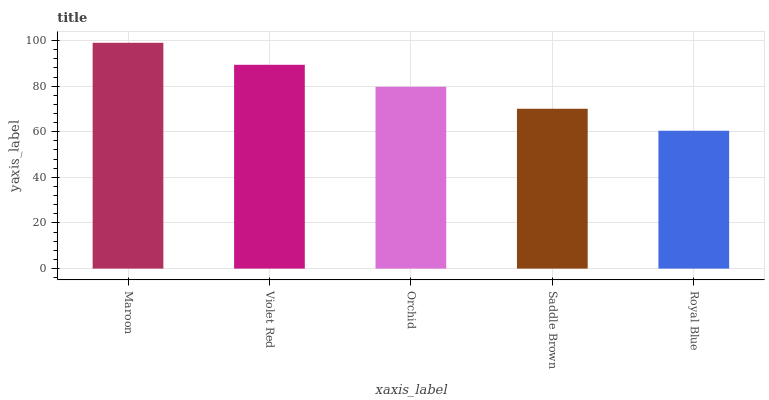Is Violet Red the minimum?
Answer yes or no. No. Is Violet Red the maximum?
Answer yes or no. No. Is Maroon greater than Violet Red?
Answer yes or no. Yes. Is Violet Red less than Maroon?
Answer yes or no. Yes. Is Violet Red greater than Maroon?
Answer yes or no. No. Is Maroon less than Violet Red?
Answer yes or no. No. Is Orchid the high median?
Answer yes or no. Yes. Is Orchid the low median?
Answer yes or no. Yes. Is Maroon the high median?
Answer yes or no. No. Is Saddle Brown the low median?
Answer yes or no. No. 